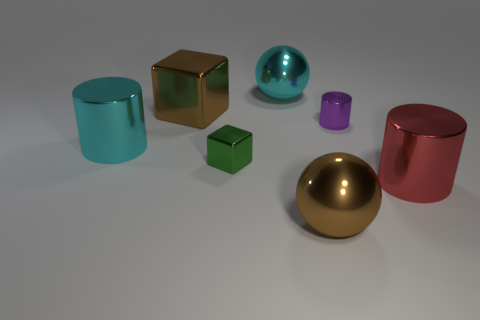There is a large sphere behind the brown ball; is its color the same as the big cylinder that is to the left of the large red metal cylinder?
Ensure brevity in your answer.  Yes. What number of small cubes are there?
Ensure brevity in your answer.  1. There is another cylinder that is the same size as the red cylinder; what color is it?
Keep it short and to the point. Cyan. Do the green shiny object and the red metallic cylinder have the same size?
Offer a terse response. No. The large metallic object that is the same color as the big cube is what shape?
Your response must be concise. Sphere. Do the green thing and the metallic sphere that is behind the small green metal object have the same size?
Ensure brevity in your answer.  No. There is a large thing that is left of the cyan metallic sphere and on the right side of the cyan shiny cylinder; what color is it?
Your answer should be very brief. Brown. Is the number of metallic things that are to the right of the tiny purple object greater than the number of tiny metal blocks in front of the green metal block?
Provide a succinct answer. Yes. The green object that is the same material as the cyan ball is what size?
Provide a succinct answer. Small. There is a large shiny sphere that is in front of the tiny green metal object; how many big shiny cylinders are on the right side of it?
Your answer should be compact. 1. 